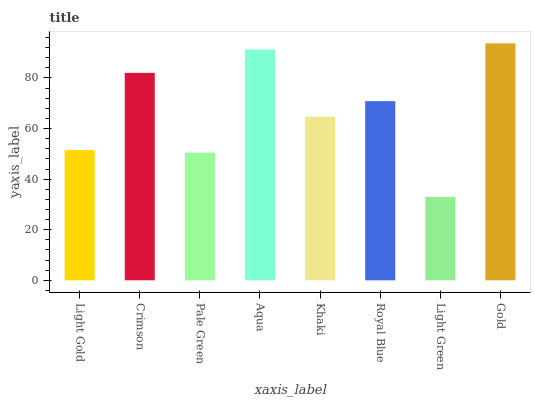Is Light Green the minimum?
Answer yes or no. Yes. Is Gold the maximum?
Answer yes or no. Yes. Is Crimson the minimum?
Answer yes or no. No. Is Crimson the maximum?
Answer yes or no. No. Is Crimson greater than Light Gold?
Answer yes or no. Yes. Is Light Gold less than Crimson?
Answer yes or no. Yes. Is Light Gold greater than Crimson?
Answer yes or no. No. Is Crimson less than Light Gold?
Answer yes or no. No. Is Royal Blue the high median?
Answer yes or no. Yes. Is Khaki the low median?
Answer yes or no. Yes. Is Aqua the high median?
Answer yes or no. No. Is Crimson the low median?
Answer yes or no. No. 